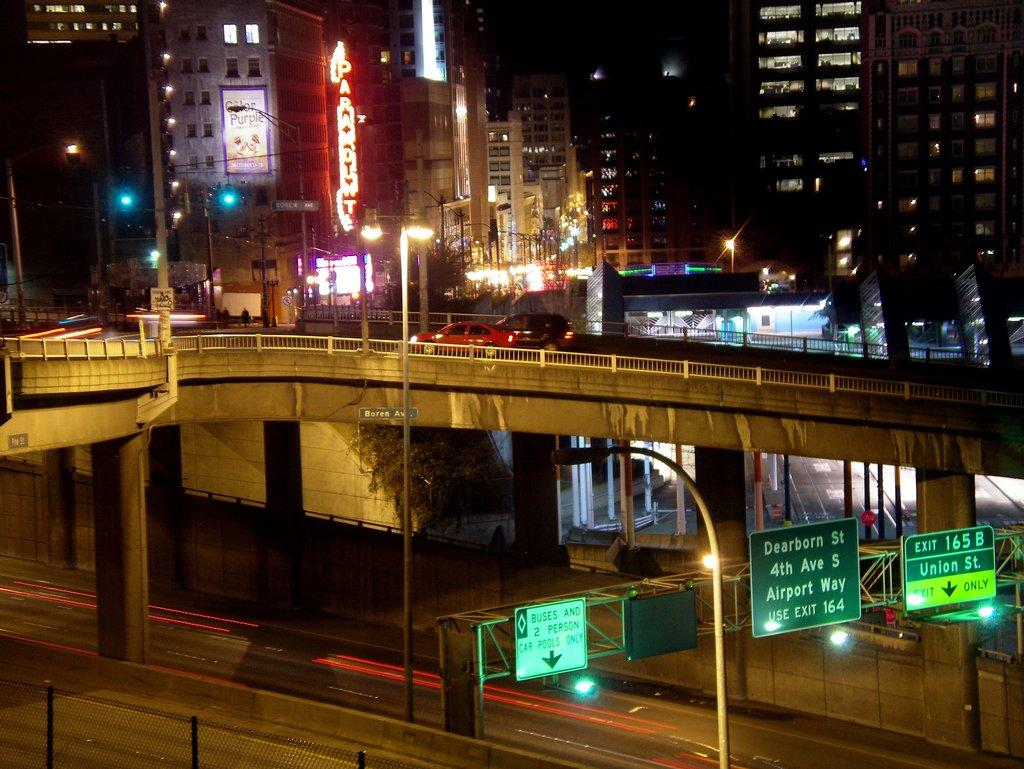What type of structure can be seen in the image? There is a fence in the image. What else can be seen in the image besides the fence? There is a road, name boards, electric poles, a bridge, vehicles, buildings, lights, and a poster visible in the image. What is the bridge used for in the image? Vehicles are on the bridge, suggesting it is used for transportation. Can you describe the background of the image? The background of the image includes buildings, lights, and a poster. What type of expert advice can be seen on the poster in the background? There is no expert advice visible on the poster in the background; it is not mentioned in the provided facts. What does your dad think about the bridge in the image? The provided facts do not mention your dad or his opinion, so it cannot be determined from the image. 